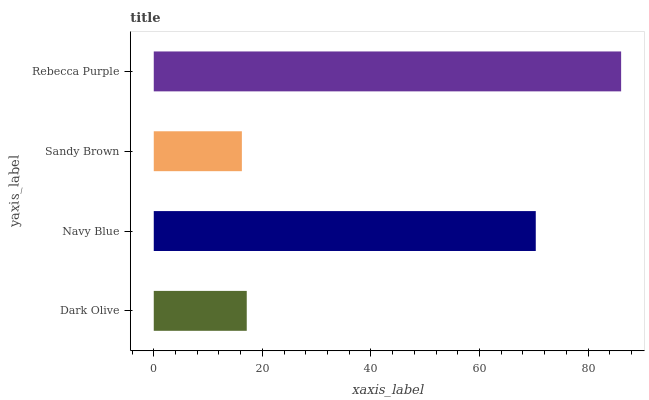Is Sandy Brown the minimum?
Answer yes or no. Yes. Is Rebecca Purple the maximum?
Answer yes or no. Yes. Is Navy Blue the minimum?
Answer yes or no. No. Is Navy Blue the maximum?
Answer yes or no. No. Is Navy Blue greater than Dark Olive?
Answer yes or no. Yes. Is Dark Olive less than Navy Blue?
Answer yes or no. Yes. Is Dark Olive greater than Navy Blue?
Answer yes or no. No. Is Navy Blue less than Dark Olive?
Answer yes or no. No. Is Navy Blue the high median?
Answer yes or no. Yes. Is Dark Olive the low median?
Answer yes or no. Yes. Is Sandy Brown the high median?
Answer yes or no. No. Is Rebecca Purple the low median?
Answer yes or no. No. 